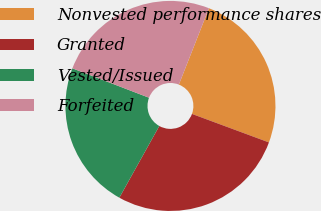<chart> <loc_0><loc_0><loc_500><loc_500><pie_chart><fcel>Nonvested performance shares<fcel>Granted<fcel>Vested/Issued<fcel>Forfeited<nl><fcel>24.67%<fcel>27.44%<fcel>22.74%<fcel>25.14%<nl></chart> 